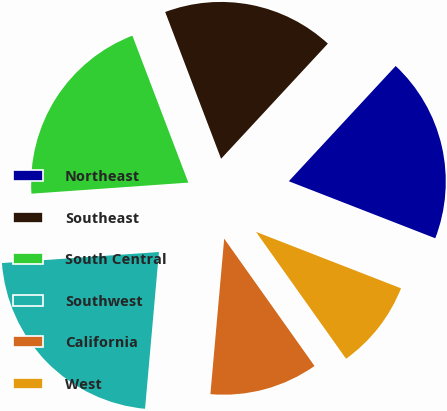Convert chart to OTSL. <chart><loc_0><loc_0><loc_500><loc_500><pie_chart><fcel>Northeast<fcel>Southeast<fcel>South Central<fcel>Southwest<fcel>California<fcel>West<nl><fcel>19.01%<fcel>17.69%<fcel>20.33%<fcel>22.47%<fcel>11.23%<fcel>9.27%<nl></chart> 